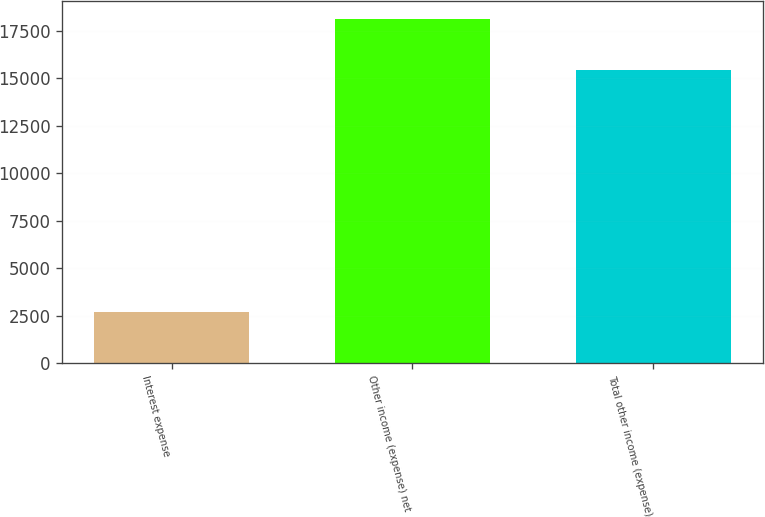<chart> <loc_0><loc_0><loc_500><loc_500><bar_chart><fcel>Interest expense<fcel>Other income (expense) net<fcel>Total other income (expense)<nl><fcel>2701<fcel>18155<fcel>15454<nl></chart> 